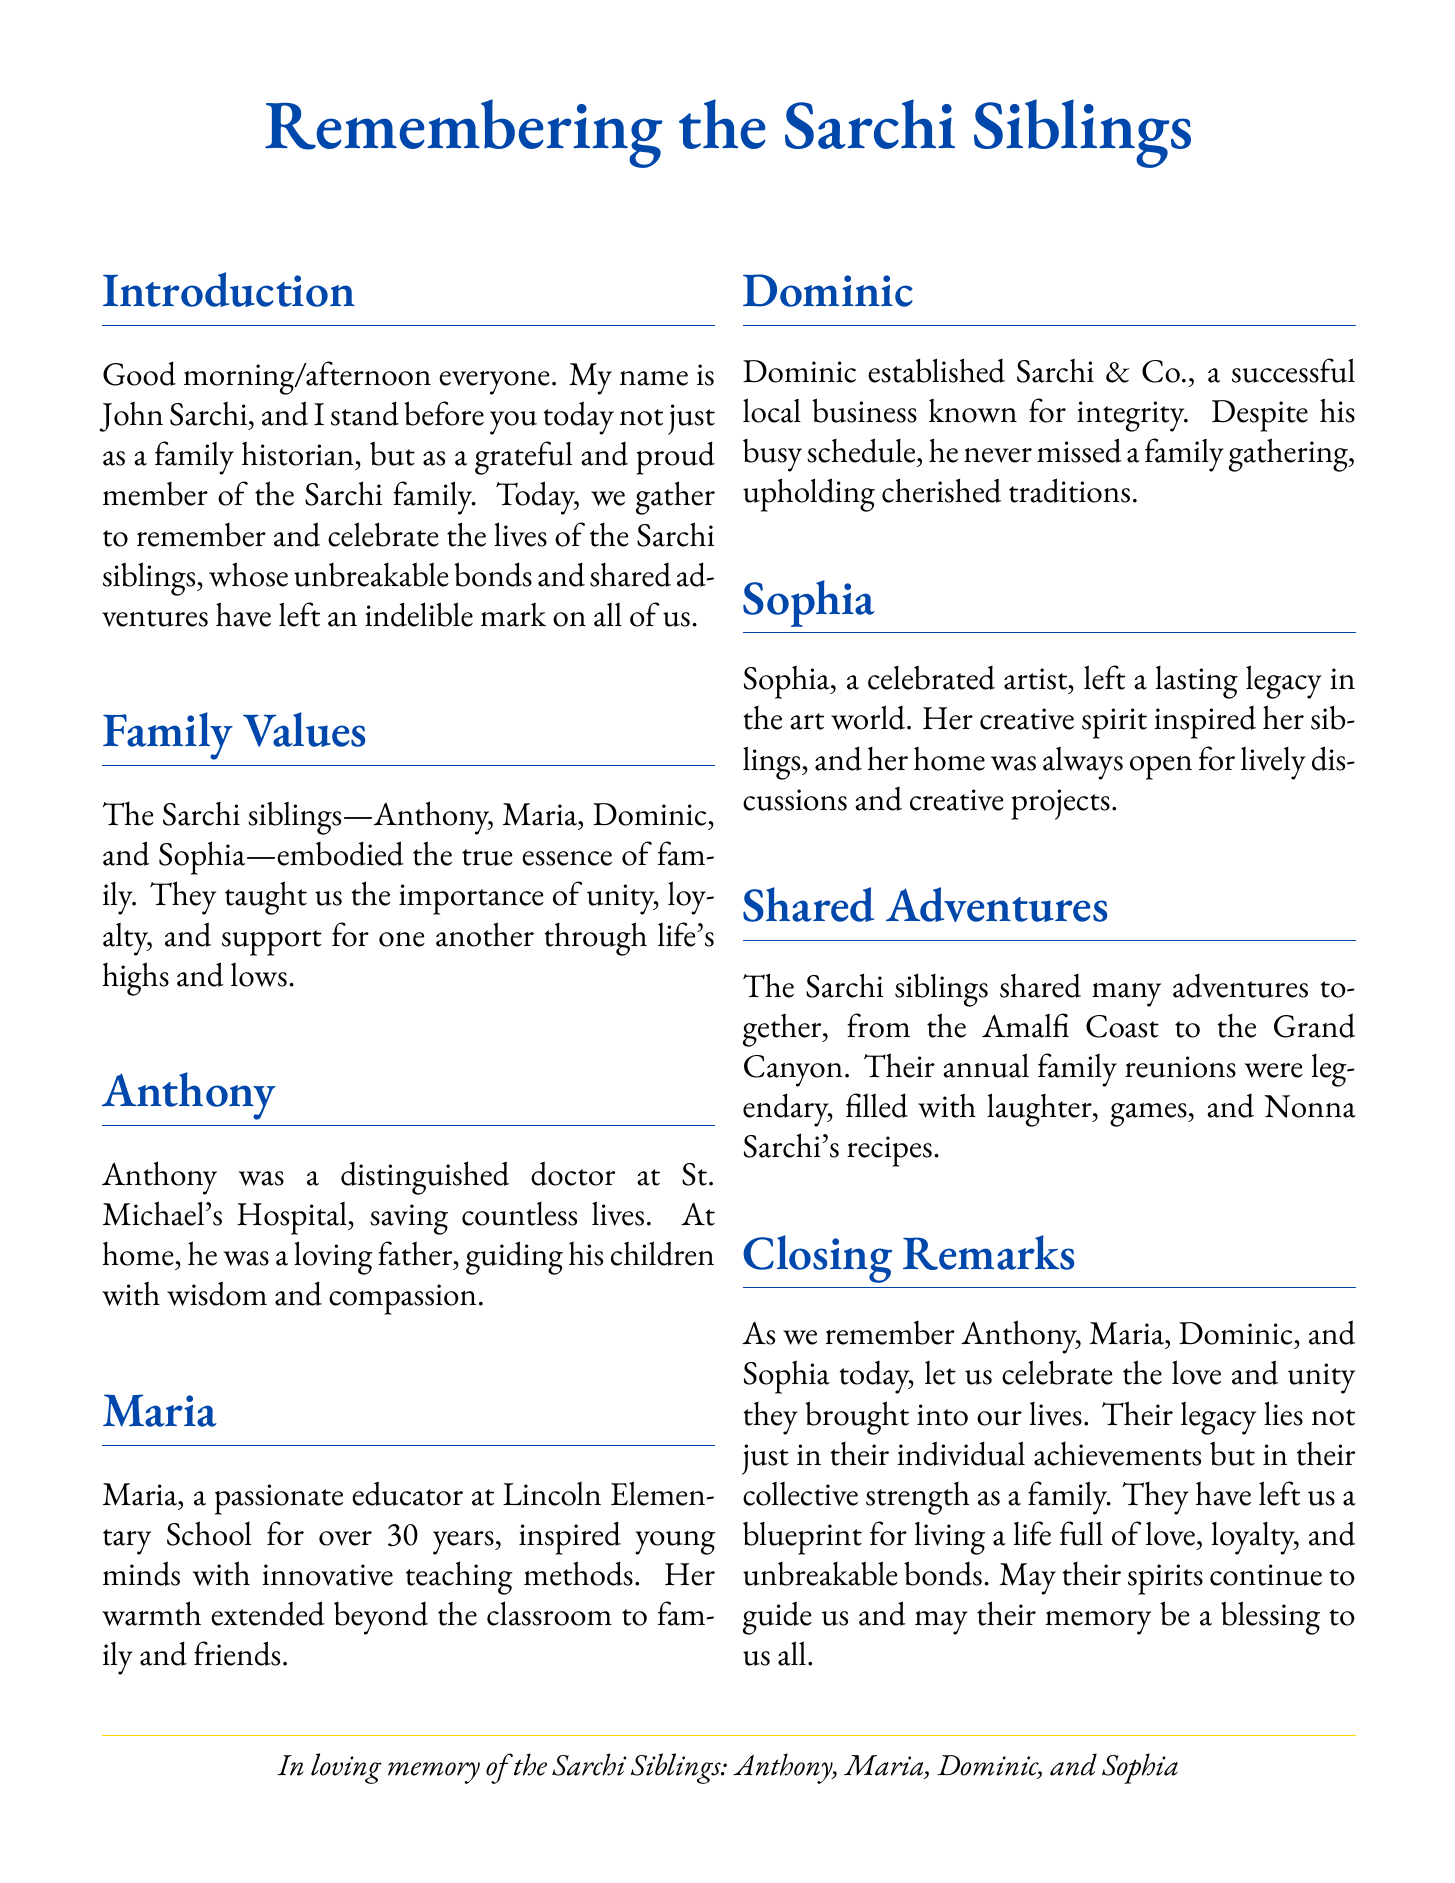What are the names of the Sarchi siblings? The document lists the names of the Sarchi siblings as Anthony, Maria, Dominic, and Sophia.
Answer: Anthony, Maria, Dominic, and Sophia Who was a distinguished doctor? The document states that Anthony was a distinguished doctor at St. Michael's Hospital.
Answer: Anthony What profession did Maria have? The document mentions that Maria was a passionate educator at Lincoln Elementary School for over 30 years.
Answer: Educator What business did Dominic establish? The document indicates that Dominic established Sarchi & Co., a successful local business.
Answer: Sarchi & Co What was Sophia's contribution to the arts? The document describes Sophia as a celebrated artist who left a lasting legacy in the art world.
Answer: Celebrated artist What values did the Sarchi siblings embody? The document states that the Sarchi siblings embodied the true essence of family, teaching unity, loyalty, and support.
Answer: Unity, loyalty, and support How long did Maria work at Lincoln Elementary School? The document notes that Maria worked at Lincoln Elementary School for over 30 years.
Answer: Over 30 years What type of adventures did the Sarchi siblings share? The document mentions that the Sarchi siblings shared adventures from the Amalfi Coast to the Grand Canyon.
Answer: Amalfi Coast to the Grand Canyon What is the purpose of this document? The document serves as a eulogy to remember and celebrate the lives of the Sarchi siblings and their contributions.
Answer: Remember and celebrate the lives of the Sarchi siblings 